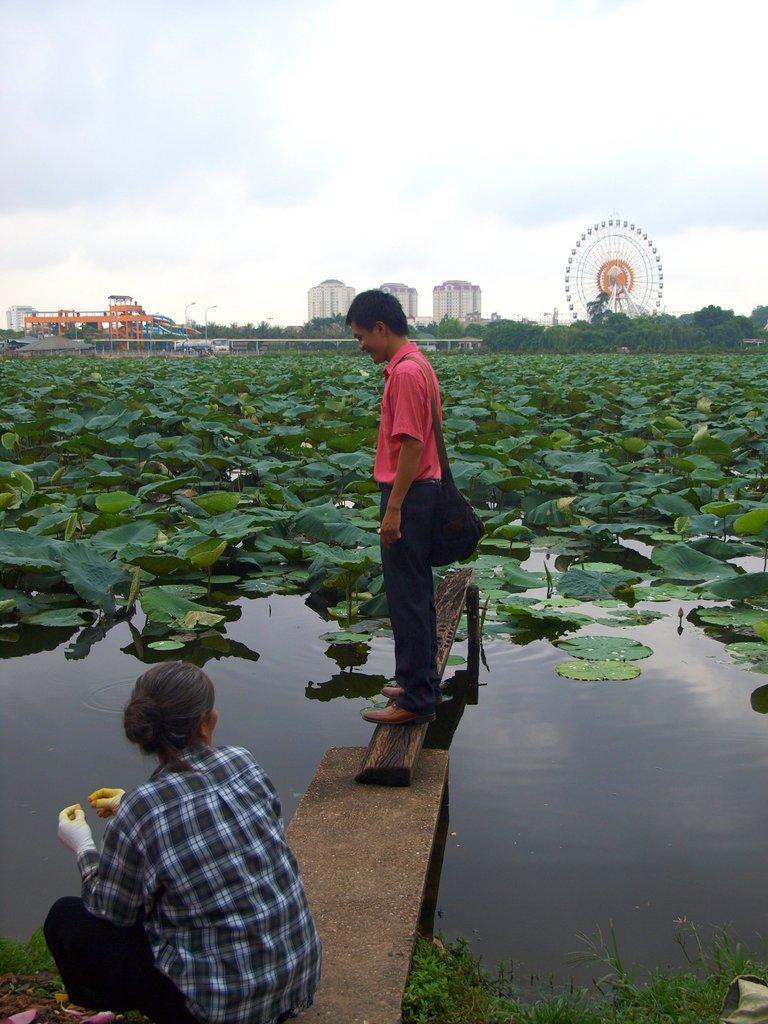Describe this image in one or two sentences. In this image a person wearing a red shirt is standing on the wooden plank and he is carrying a bag. He is wearing shoes. Behind him there are few plants in water. Bottom of image there is a person sitting on the stone slab. He is wearing a shirt and gloves. Middle of image there are few buildings, gain wheel and few trees. Top of image there is sky. 